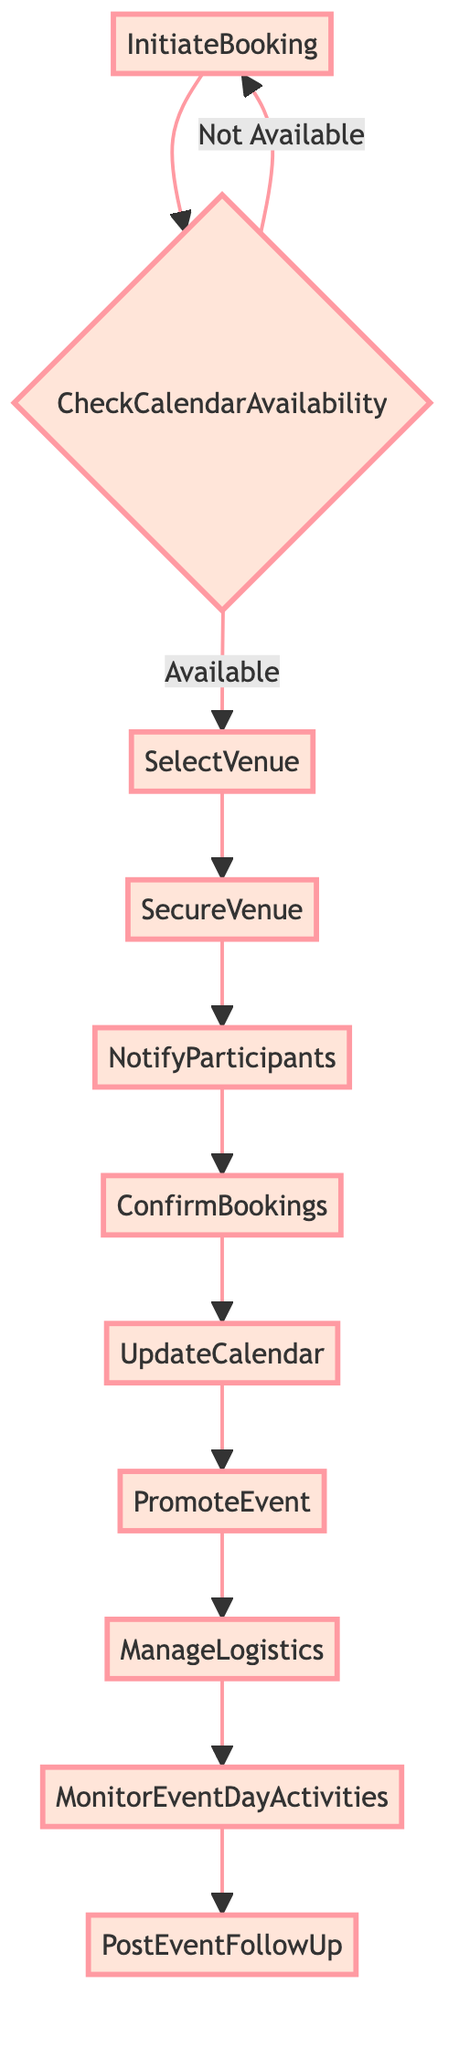What is the first step in the event booking process? The first step, as indicated in the diagram, is "InitiateBooking". This is the starting point for booking a new racing event.
Answer: InitiateBooking What happens if the desired dates and venues are not available? If the desired dates and venues are not available, the flowchart shows that the process would revert back to the "InitiateBooking" step, indicating that the user would need to start over.
Answer: InitiateBooking How many total steps are there in the diagram? By counting the nodes in the diagram, it can be noted that there are 11 steps in total, ranging from "InitiateBooking" to "PostEventFollowUp".
Answer: 11 What is the final step in the booking process? The final step in the process, as shown in the diagram, is "PostEventFollowUp". This step includes review, feedback collection, and expense settlements after the event.
Answer: PostEventFollowUp Which step follows "ConfirmBookings"? According to the flowchart, the step that follows "ConfirmBookings" is "UpdateCalendar". This indicates that once bookings are confirmed, the event details are then added to the calendar.
Answer: UpdateCalendar What does the "ManageLogistics" step involve? The "ManageLogistics" step involves coordinating with logistics teams for event setup, which includes stabling, track preparation, and equipment. This is crucial for ensuring the event runs smoothly.
Answer: Coordinate with logistics teams If the initial checks show availability, what is the next action? If the calendar availability check shows that dates and venues are available, the next action is to "SelectVenue". This reflects that the process then moves forward to choosing a racing track.
Answer: SelectVenue What type of notifications are sent in the "NotifyParticipants" step? In the "NotifyParticipants" step, notifications are sent to jockeys, trainers, and other stakeholders informing them about the new event, ensuring all parties are aware and can make necessary preparations.
Answer: Notifications to jockeys, trainers, and stakeholders What promotion activities are launched after updating the calendar? After updating the calendar, the process includes "PromoteEvent", which consists of launching promotional activities to attract spectators and media attention for the event.
Answer: Launch promotional activities 